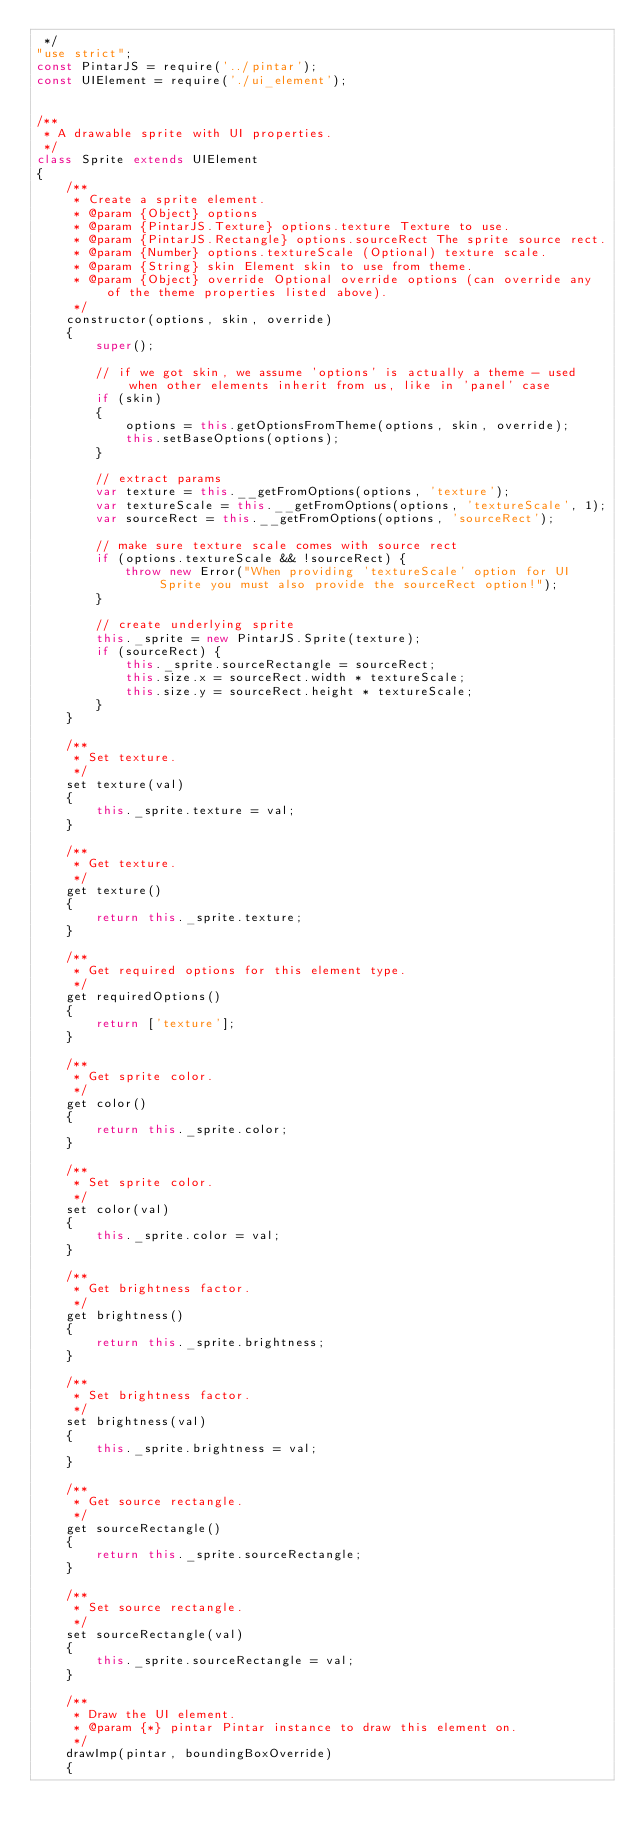<code> <loc_0><loc_0><loc_500><loc_500><_JavaScript_> */
"use strict";
const PintarJS = require('../pintar');
const UIElement = require('./ui_element');


/**
 * A drawable sprite with UI properties.
 */
class Sprite extends UIElement
{
    /**
     * Create a sprite element.
     * @param {Object} options
     * @param {PintarJS.Texture} options.texture Texture to use.
     * @param {PintarJS.Rectangle} options.sourceRect The sprite source rect.
     * @param {Number} options.textureScale (Optional) texture scale.
     * @param {String} skin Element skin to use from theme.
     * @param {Object} override Optional override options (can override any of the theme properties listed above).
     */
    constructor(options, skin, override)
    {
        super();

        // if we got skin, we assume 'options' is actually a theme - used when other elements inherit from us, like in 'panel' case
        if (skin) 
        {
            options = this.getOptionsFromTheme(options, skin, override);
            this.setBaseOptions(options);
        }

        // extract params
        var texture = this.__getFromOptions(options, 'texture');
        var textureScale = this.__getFromOptions(options, 'textureScale', 1);
        var sourceRect = this.__getFromOptions(options, 'sourceRect');

        // make sure texture scale comes with source rect
        if (options.textureScale && !sourceRect) {
            throw new Error("When providing 'textureScale' option for UI Sprite you must also provide the sourceRect option!");
        }
        
        // create underlying sprite
        this._sprite = new PintarJS.Sprite(texture);
        if (sourceRect) { 
            this._sprite.sourceRectangle = sourceRect; 
            this.size.x = sourceRect.width * textureScale;
            this.size.y = sourceRect.height * textureScale;
        }
    }

    /**
     * Set texture.
     */
    set texture(val)
    {
        this._sprite.texture = val;
    }

    /**
     * Get texture.
     */
    get texture()
    {
        return this._sprite.texture;
    }

    /**
     * Get required options for this element type.
     */
    get requiredOptions()
    {
        return ['texture'];
    }

    /**
     * Get sprite color.
     */
    get color()
    {
        return this._sprite.color;
    }

    /**
     * Set sprite color.
     */
    set color(val)
    {
        this._sprite.color = val;
    }

    /**
     * Get brightness factor.
     */
    get brightness()
    {
        return this._sprite.brightness;
    }

    /**
     * Set brightness factor.
     */
    set brightness(val)
    {
        this._sprite.brightness = val;
    }

    /**
     * Get source rectangle.
     */
    get sourceRectangle()
    {
        return this._sprite.sourceRectangle;
    }

    /**
     * Set source rectangle.
     */
    set sourceRectangle(val)
    {
        this._sprite.sourceRectangle = val;
    }

    /**
     * Draw the UI element.
     * @param {*} pintar Pintar instance to draw this element on.
     */
    drawImp(pintar, boundingBoxOverride)
    {</code> 